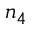<formula> <loc_0><loc_0><loc_500><loc_500>n _ { 4 }</formula> 